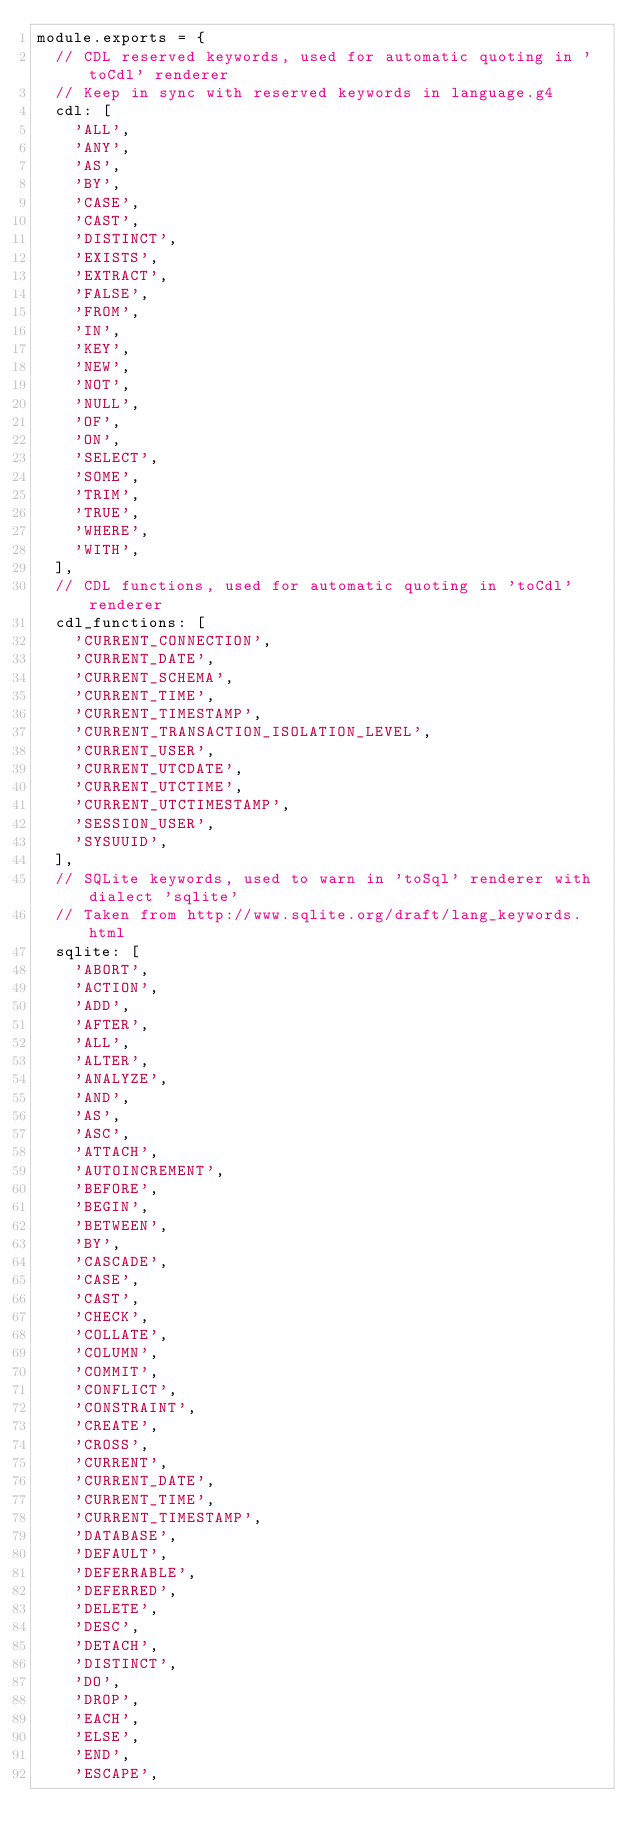<code> <loc_0><loc_0><loc_500><loc_500><_JavaScript_>module.exports = {
  // CDL reserved keywords, used for automatic quoting in 'toCdl' renderer
  // Keep in sync with reserved keywords in language.g4
  cdl: [
    'ALL',
    'ANY',
    'AS',
    'BY',
    'CASE',
    'CAST',
    'DISTINCT',
    'EXISTS',
    'EXTRACT',
    'FALSE',
    'FROM',
    'IN',
    'KEY',
    'NEW',
    'NOT',
    'NULL',
    'OF',
    'ON',
    'SELECT',
    'SOME',
    'TRIM',
    'TRUE',
    'WHERE',
    'WITH',
  ],
  // CDL functions, used for automatic quoting in 'toCdl' renderer
  cdl_functions: [
    'CURRENT_CONNECTION',
    'CURRENT_DATE',
    'CURRENT_SCHEMA',
    'CURRENT_TIME',
    'CURRENT_TIMESTAMP',
    'CURRENT_TRANSACTION_ISOLATION_LEVEL',
    'CURRENT_USER',
    'CURRENT_UTCDATE',
    'CURRENT_UTCTIME',
    'CURRENT_UTCTIMESTAMP',
    'SESSION_USER',
    'SYSUUID',
  ],
  // SQLite keywords, used to warn in 'toSql' renderer with dialect 'sqlite'
  // Taken from http://www.sqlite.org/draft/lang_keywords.html
  sqlite: [
    'ABORT',
    'ACTION',
    'ADD',
    'AFTER',
    'ALL',
    'ALTER',
    'ANALYZE',
    'AND',
    'AS',
    'ASC',
    'ATTACH',
    'AUTOINCREMENT',
    'BEFORE',
    'BEGIN',
    'BETWEEN',
    'BY',
    'CASCADE',
    'CASE',
    'CAST',
    'CHECK',
    'COLLATE',
    'COLUMN',
    'COMMIT',
    'CONFLICT',
    'CONSTRAINT',
    'CREATE',
    'CROSS',
    'CURRENT',
    'CURRENT_DATE',
    'CURRENT_TIME',
    'CURRENT_TIMESTAMP',
    'DATABASE',
    'DEFAULT',
    'DEFERRABLE',
    'DEFERRED',
    'DELETE',
    'DESC',
    'DETACH',
    'DISTINCT',
    'DO',
    'DROP',
    'EACH',
    'ELSE',
    'END',
    'ESCAPE',</code> 